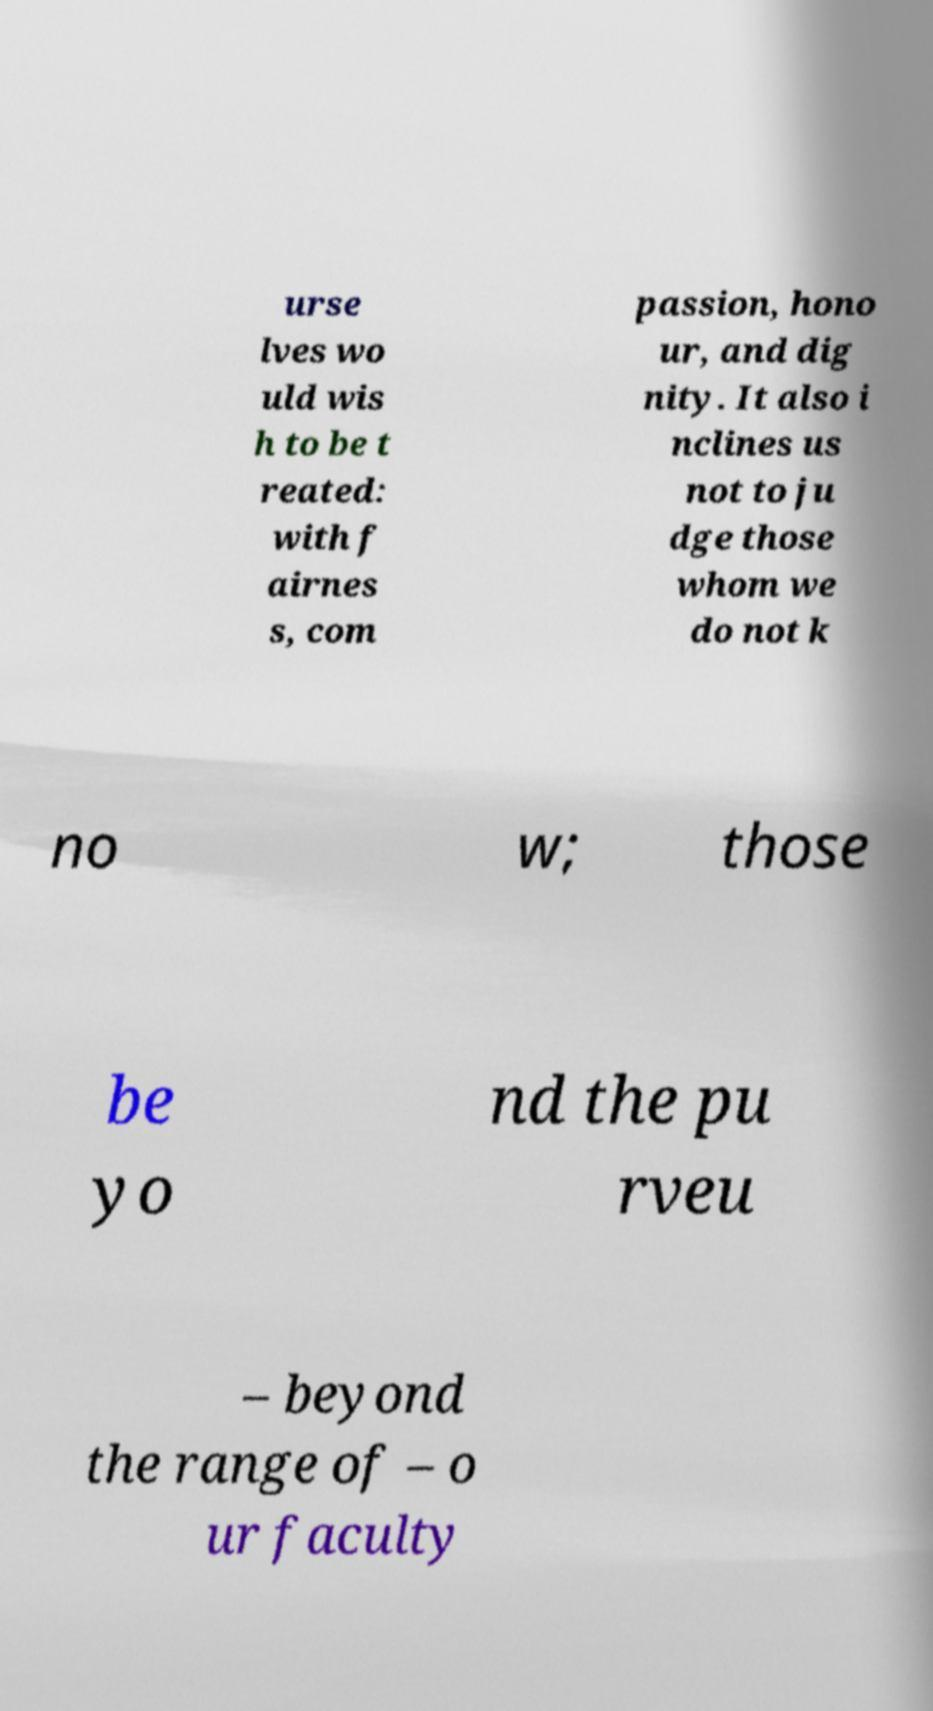There's text embedded in this image that I need extracted. Can you transcribe it verbatim? urse lves wo uld wis h to be t reated: with f airnes s, com passion, hono ur, and dig nity. It also i nclines us not to ju dge those whom we do not k no w; those be yo nd the pu rveu – beyond the range of – o ur faculty 